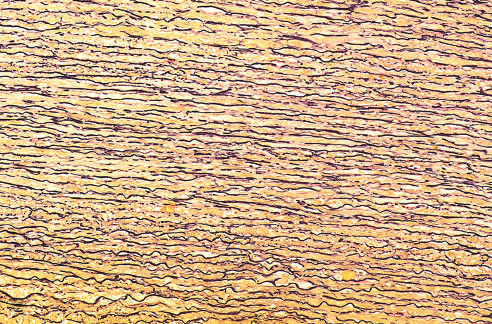what shows the regular layered pattern of elastic tissue?
Answer the question using a single word or phrase. Normal media for comparison 